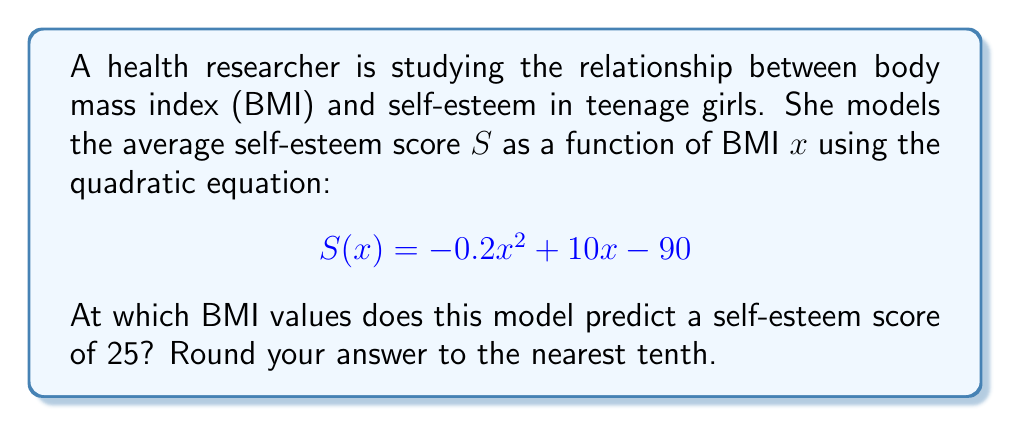What is the answer to this math problem? To find the BMI values where the self-esteem score is 25, we need to solve the equation:

$$ -0.2x^2 + 10x - 90 = 25 $$

Let's solve this step-by-step:

1) First, move all terms to one side of the equation:
   $$ -0.2x^2 + 10x - 115 = 0 $$

2) This is a quadratic equation in the standard form $ax^2 + bx + c = 0$, where:
   $a = -0.2$, $b = 10$, and $c = -115$

3) We can solve this using the quadratic formula: $x = \frac{-b \pm \sqrt{b^2 - 4ac}}{2a}$

4) Let's substitute our values:
   $$ x = \frac{-10 \pm \sqrt{10^2 - 4(-0.2)(-115)}}{2(-0.2)} $$

5) Simplify under the square root:
   $$ x = \frac{-10 \pm \sqrt{100 - 92}}{-0.4} = \frac{-10 \pm \sqrt{8}}{-0.4} $$

6) Simplify $\sqrt{8}$:
   $$ x = \frac{-10 \pm 2\sqrt{2}}{-0.4} $$

7) Calculate the two solutions:
   $$ x_1 = \frac{-10 + 2\sqrt{2}}{-0.4} \approx 21.8 $$
   $$ x_2 = \frac{-10 - 2\sqrt{2}}{-0.4} \approx 28.2 $$

8) Rounding to the nearest tenth:
   $x_1 \approx 21.8$ and $x_2 \approx 28.2$
Answer: The model predicts a self-esteem score of 25 at BMI values of approximately 21.8 and 28.2. 